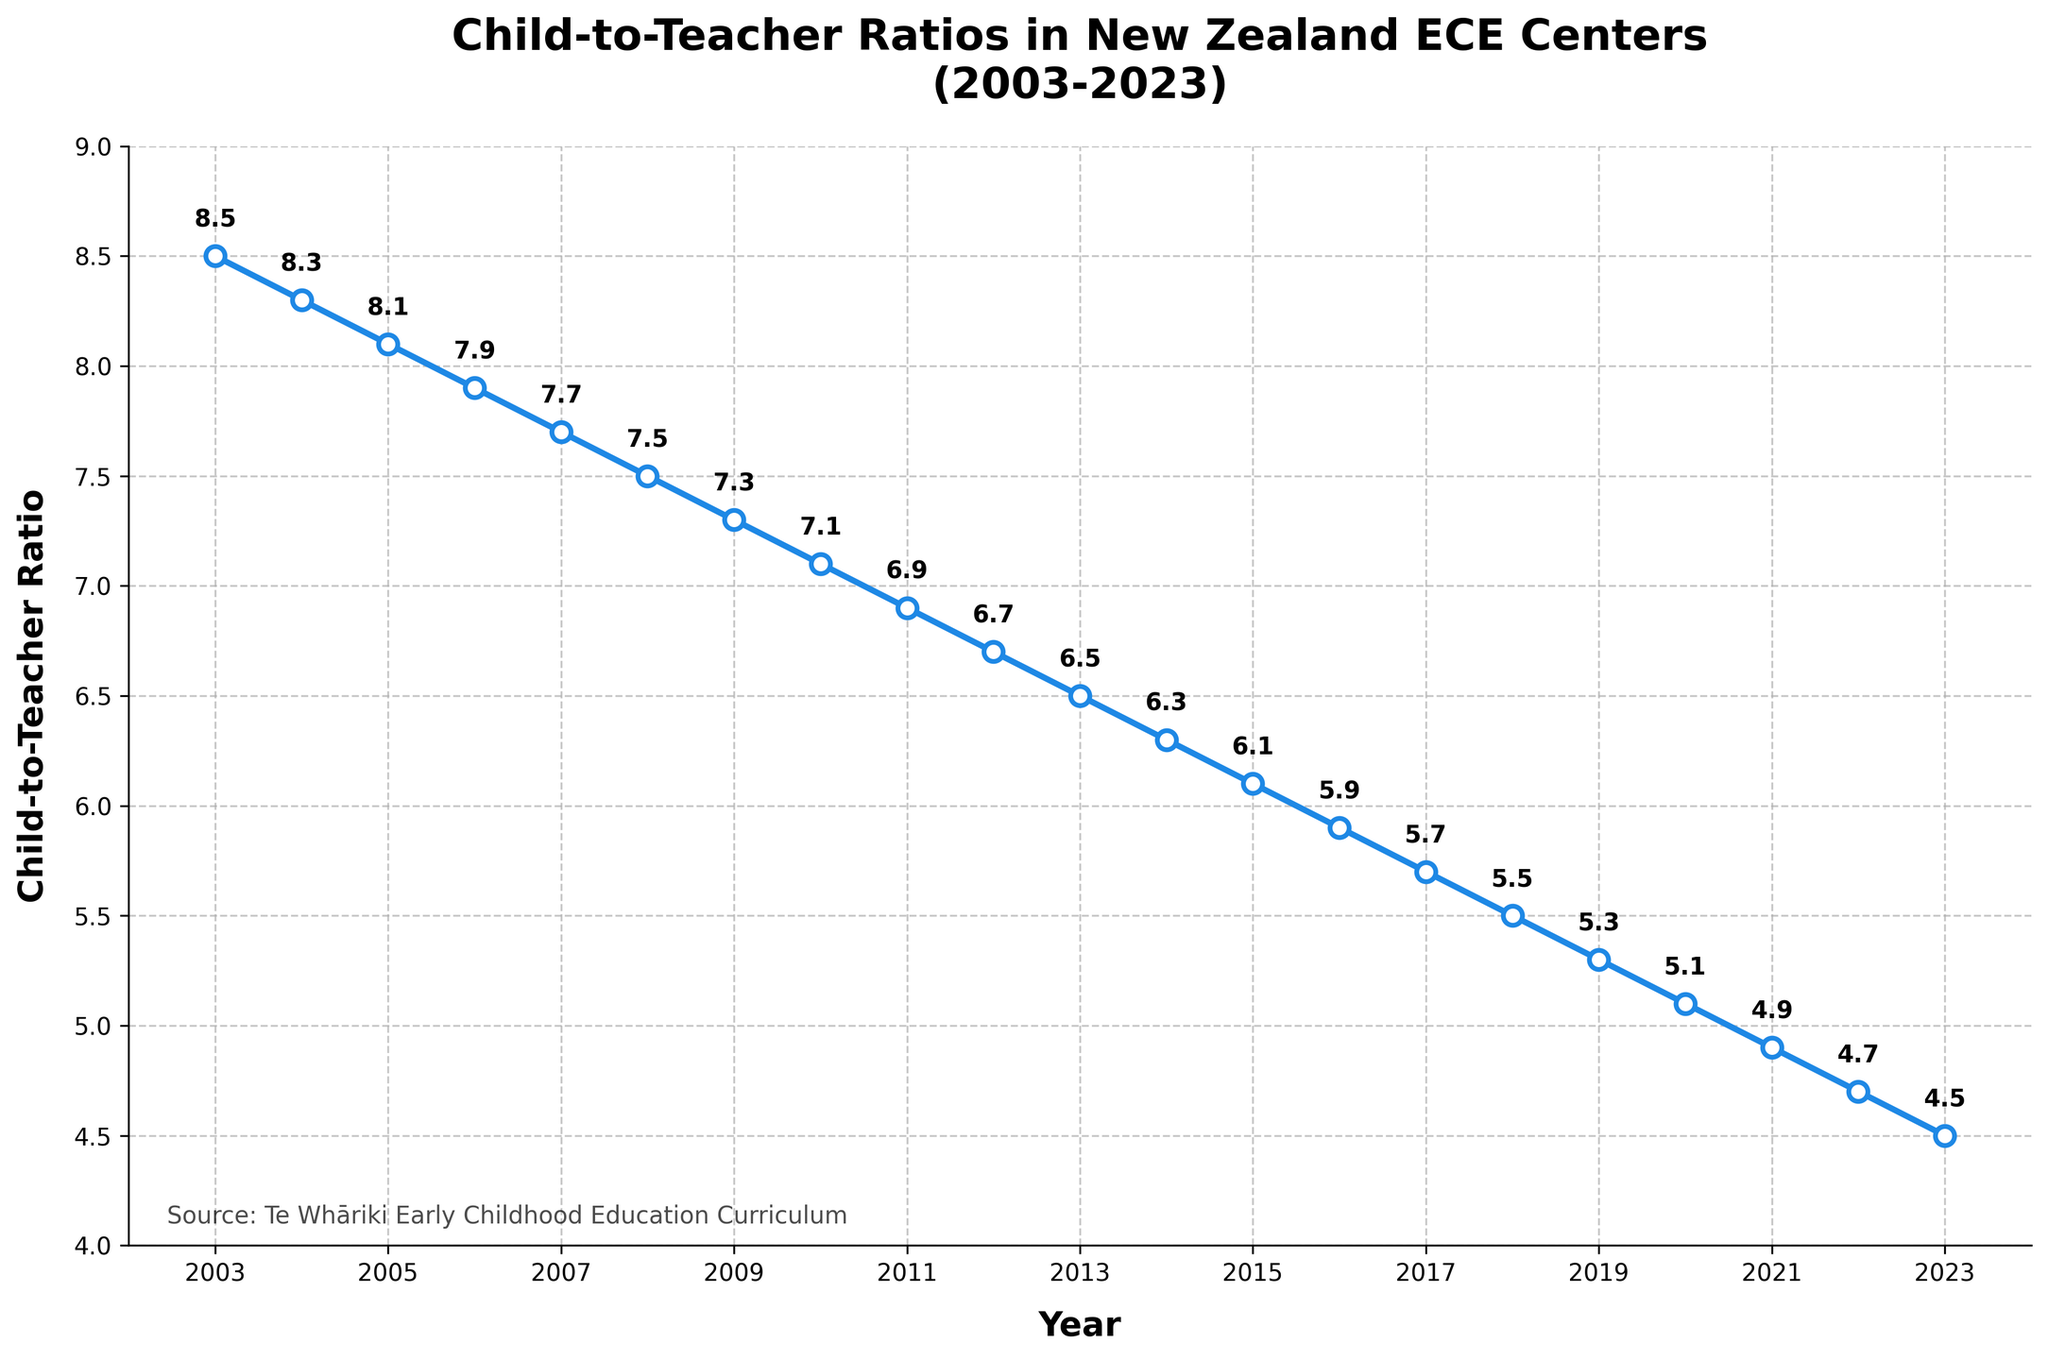How does the child-to-teacher ratio in 2023 compare to that in 2003? The ratio in 2003 is 8.5 and in 2023 it is 4.5. The difference is 8.5 - 4.5 = 4.0.
Answer: The ratio in 2023 is 4.0 lower than in 2003 Which year saw the largest single-year drop in the child-to-teacher ratio? By examining each yearly decrease, 2008 to 2009 drops from 7.5 to 7.3, which is a 0.2 decrease. The largest drop occurs from 2021 (4.9) to 2022 (4.7), a 0.2 decrease.
Answer: 2021 to 2022 What is the average child-to-teacher ratio over the entire period? Sum all the ratios from 2003 to 2023 and divide by the number of years (21). (8.5 + 8.3 + 8.1 + 7.9 + 7.7 + 7.5 + 7.3 + 7.1 + 6.9 + 6.7 + 6.5 + 6.3 + 6.1 + 5.9 + 5.7 + 5.5 + 5.3 + 5.1 + 4.9 + 4.7 + 4.5) / 21 = 6.57
Answer: 6.57 Which year marked the halfway point in the decline of the child-to-teacher ratio from 2003 to 2023? A decrease of 4.0 over 20 years suggests a halfway point decrease of 2.0, reaching a ratio of 6.5. In 2013, the ratio is 6.5.
Answer: 2013 What is the median child-to-teacher ratio over the period? List all the ratios from least to greatest and find the middle value: 4.5, 4.7, 4.9, 5.1, 5.3, 5.5, 5.7, 5.9, 6.1, 6.3, 6.5, 6.7, 6.9, 7.1, 7.3, 7.5, 7.7, 7.9, 8.1, 8.3, 8.5. The median is the middle value: 6.5.
Answer: 6.5 How does the child-to-teacher ratio change visually between 2003 and 2023? The blue line slopes downward from 2003 to 2023, showing a consistent decline. Each year, markers show ratios decreasing steadily.
Answer: The ratio decreases steadily Which 5-year period saw the most significant decrease in child-to-teacher ratios? Examine the beginning and end of each 5-year period; the most significant drop happens between 2007 (7.7) and 2012 (6.7), a difference of 1.0.
Answer: 2007-2012 In what year did the child-to-teacher ratio first drop below 6.0? Observing the decrease, the ratio first falls below 6.0 in 2016 (5.9).
Answer: 2016 What would be a plausible reason for the consistent decrease in the child-to-teacher ratio over the years? Integrate the likely focus on quality in early childhood education, supported by Te Whāriki which emphasizes good teacher-child interaction.
Answer: Increased focus on educational quality How would you describe the trend shown in the chart? The trend is a gradual, consistent decline in the child-to-teacher ratio over 20 years, indicating improvements in teacher availability and potentially educational focus.
Answer: Gradual consistent decline 